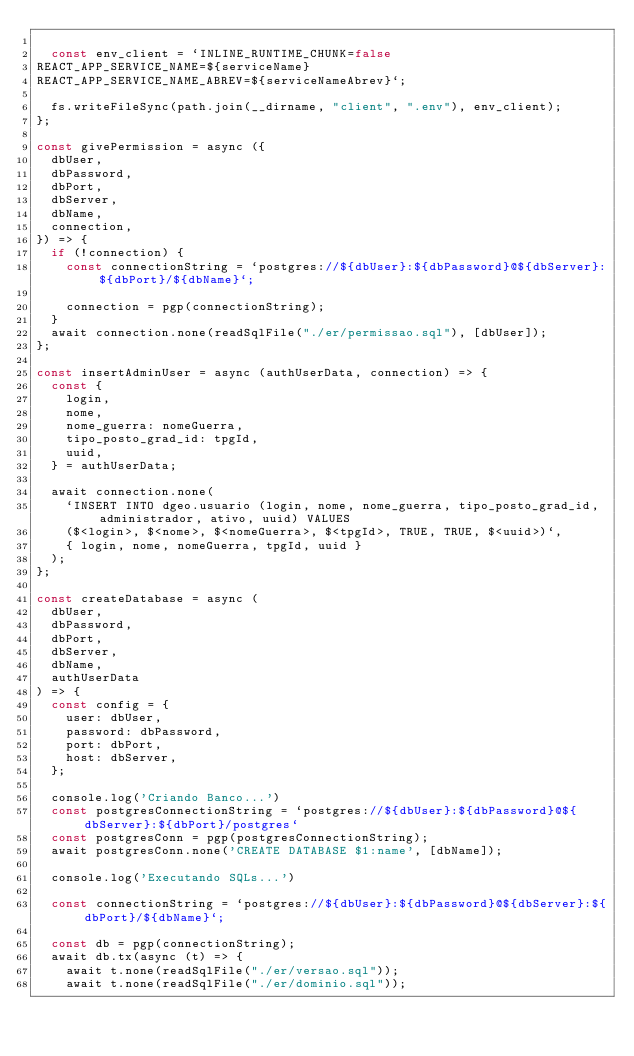Convert code to text. <code><loc_0><loc_0><loc_500><loc_500><_JavaScript_>
  const env_client = `INLINE_RUNTIME_CHUNK=false
REACT_APP_SERVICE_NAME=${serviceName}
REACT_APP_SERVICE_NAME_ABREV=${serviceNameAbrev}`;

  fs.writeFileSync(path.join(__dirname, "client", ".env"), env_client);
};

const givePermission = async ({
  dbUser,
  dbPassword,
  dbPort,
  dbServer,
  dbName,
  connection,
}) => {
  if (!connection) {
    const connectionString = `postgres://${dbUser}:${dbPassword}@${dbServer}:${dbPort}/${dbName}`;

    connection = pgp(connectionString);
  }
  await connection.none(readSqlFile("./er/permissao.sql"), [dbUser]);
};

const insertAdminUser = async (authUserData, connection) => {
  const {
    login,
    nome,
    nome_guerra: nomeGuerra,
    tipo_posto_grad_id: tpgId,
    uuid,
  } = authUserData;

  await connection.none(
    `INSERT INTO dgeo.usuario (login, nome, nome_guerra, tipo_posto_grad_id, administrador, ativo, uuid) VALUES
    ($<login>, $<nome>, $<nomeGuerra>, $<tpgId>, TRUE, TRUE, $<uuid>)`,
    { login, nome, nomeGuerra, tpgId, uuid }
  );
};

const createDatabase = async (
  dbUser,
  dbPassword,
  dbPort,
  dbServer,
  dbName,
  authUserData
) => {
  const config = {
    user: dbUser,
    password: dbPassword,
    port: dbPort,
    host: dbServer,
  };

  console.log('Criando Banco...')
  const postgresConnectionString = `postgres://${dbUser}:${dbPassword}@${dbServer}:${dbPort}/postgres`
  const postgresConn = pgp(postgresConnectionString);
  await postgresConn.none('CREATE DATABASE $1:name', [dbName]);

  console.log('Executando SQLs...')

  const connectionString = `postgres://${dbUser}:${dbPassword}@${dbServer}:${dbPort}/${dbName}`;

  const db = pgp(connectionString);
  await db.tx(async (t) => {
    await t.none(readSqlFile("./er/versao.sql"));
    await t.none(readSqlFile("./er/dominio.sql"));</code> 